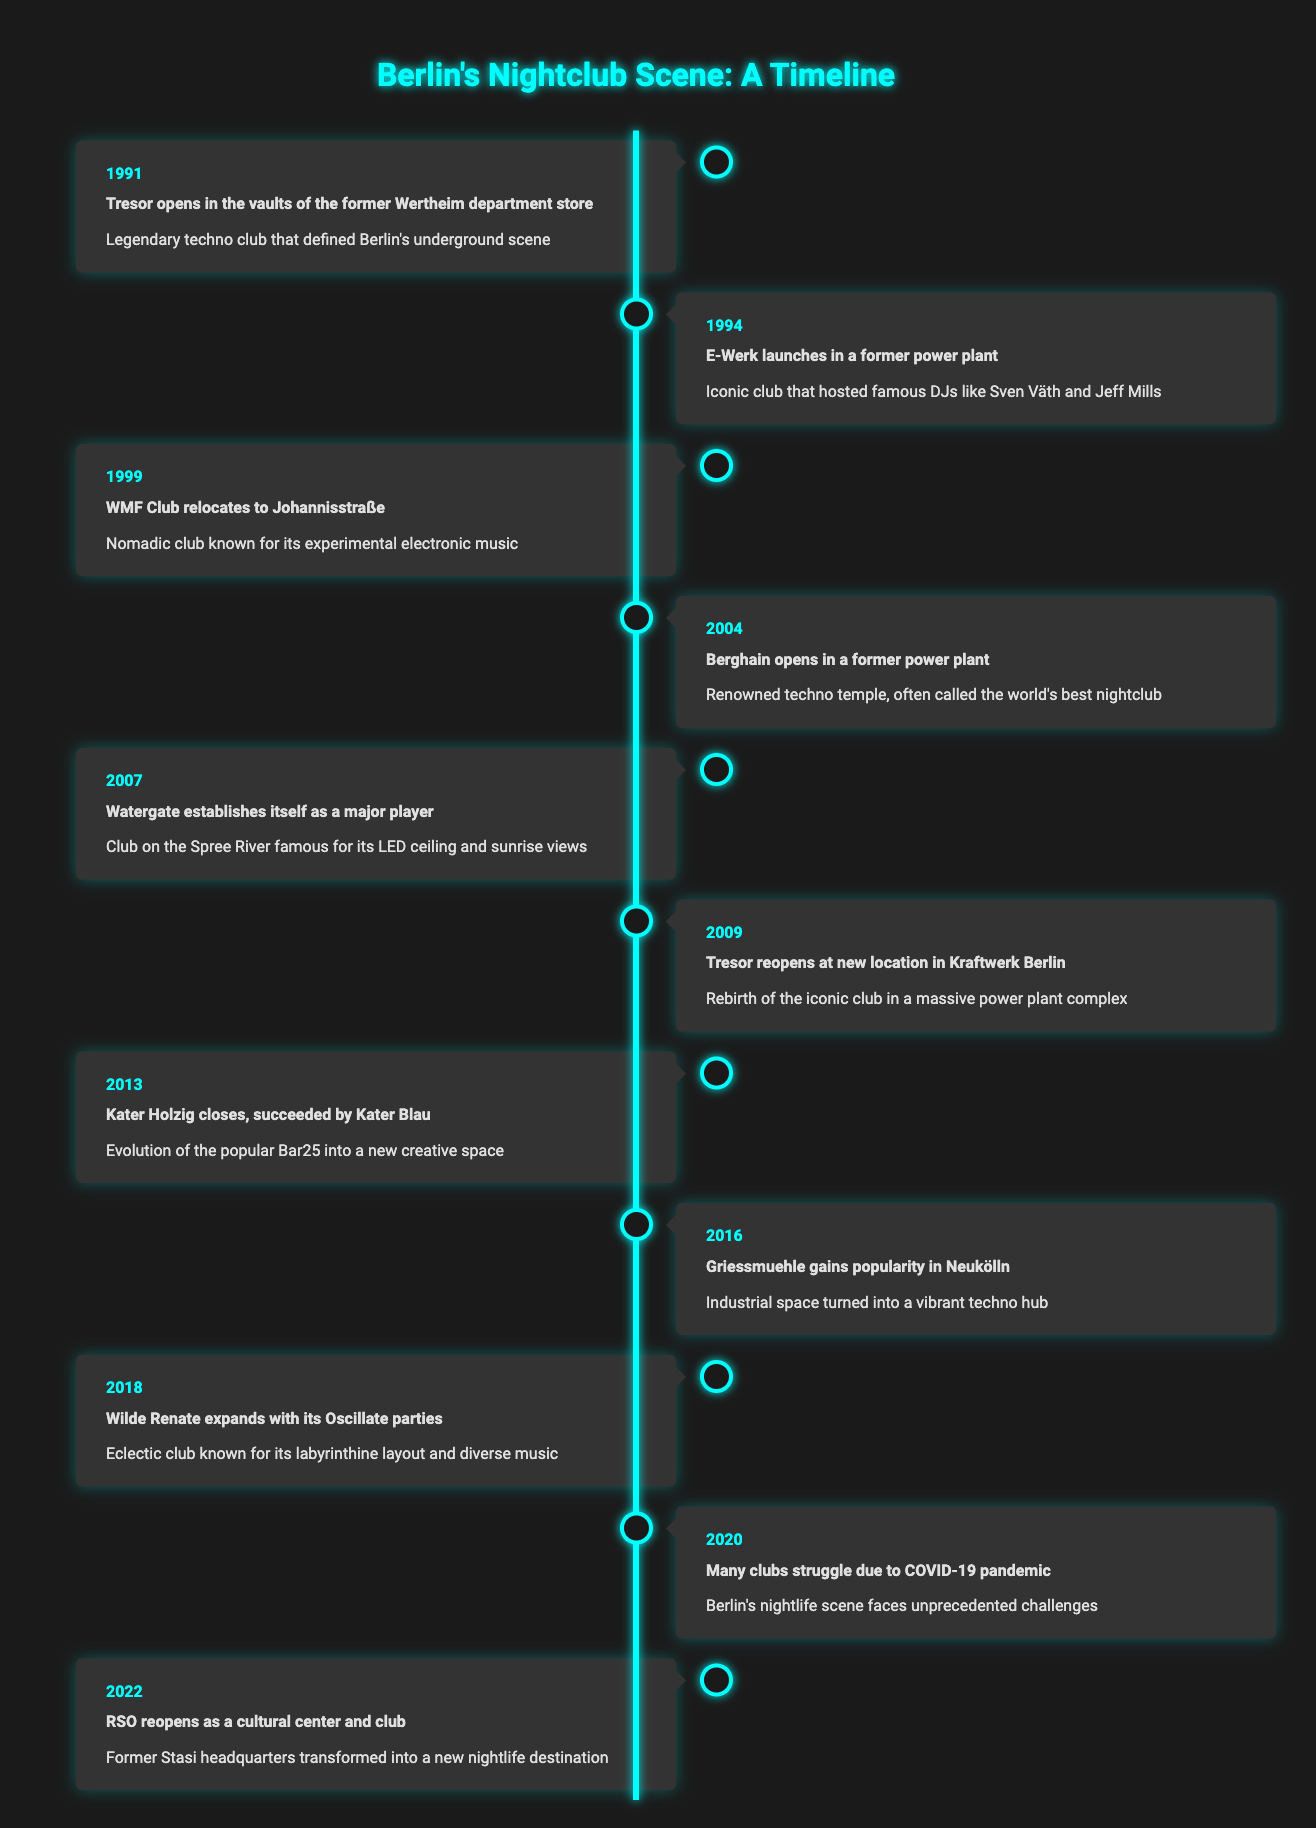What year did Tresor first open? The table lists opening years for various clubs. Looking at the row for Tresor, the year mentioned is 1991.
Answer: 1991 Which club opened in a former power plant in 2004? Referring to the 2004 entry in the table, it shows that Berghain opened in a former power plant.
Answer: Berghain How many years passed between the opening of E-Werk and Berghain? E-Werk opened in 1994 and Berghain opened in 2004. The difference is 2004 - 1994 = 10 years.
Answer: 10 years Did Kater Holzig succeed Kater Blau? The table states that Kater Holzig closed and was succeeded by Kater Blau in 2013. Therefore, the statement is true.
Answer: Yes What club is known for its LED ceiling and sunrise views? According to the entry for 2007, Watergate is described as the club famous for its LED ceiling and views of the sunrise.
Answer: Watergate Which clubs faced struggles due to the COVID-19 pandemic, and in what year? The table indicates in 2020 that many clubs struggled due to the pandemic. It doesn't specify names, but generally refers to all clubs during that year.
Answer: Many clubs in 2020 What is the significance of Tresor's reopening in 2009? The entry for 2009 mentions that Tresor reopened at a new location in Kraftwerk Berlin, marking a rebirth of the iconic club. This suggests its importance in maintaining Berlin's nightlife culture.
Answer: Rebirth in Kraftwerk Berlin Name the club that relayed its significance as a vibrant techno hub in 2016. The description for 2016 mentions Griessmuehle as gaining popularity in Neukölln, being an industrial space turned vibrant techno hub.
Answer: Griessmuehle How many clubs are mentioned as opening or reopening from 1991 to 2022? The timeline includes 10 significant events regarding nightclub openings or re-openings from 1991 to 2022, counted from each entry.
Answer: 10 clubs 